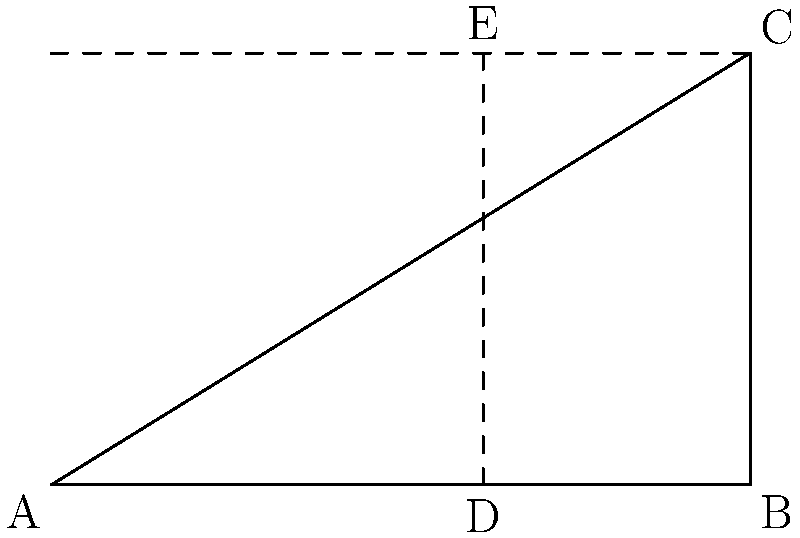In a nature photograph composition, you're using the golden ratio to create a visually pleasing image. The photograph is represented by the rectangle ABCE, where AB = 100 units and BC = 61.8 units. Point D divides AB according to the golden ratio. If AD:DB follows the golden ratio, calculate the length of AD to two decimal places. To solve this problem, we'll use the properties of the golden ratio and the given information:

1) The golden ratio is approximately 1.618033988749895, often denoted by φ (phi).

2) In a golden rectangle, the ratio of the longer side to the shorter side is equal to φ.

3) Given: AB = 100 units, BC = 61.8 units

4) The golden ratio states that:
   $\frac{AB}{BC} = \frac{BC}{AD} = φ$

5) We can set up the equation:
   $\frac{100}{61.8} = \frac{61.8}{AD} = φ$

6) From this, we can derive:
   $AD = \frac{61.8}{φ} = \frac{61.8}{1.618033988749895}$

7) Calculating this:
   $AD ≈ 38.19660112501051$

8) Rounding to two decimal places:
   $AD ≈ 38.20$ units

Therefore, the length of AD is approximately 38.20 units.
Answer: 38.20 units 